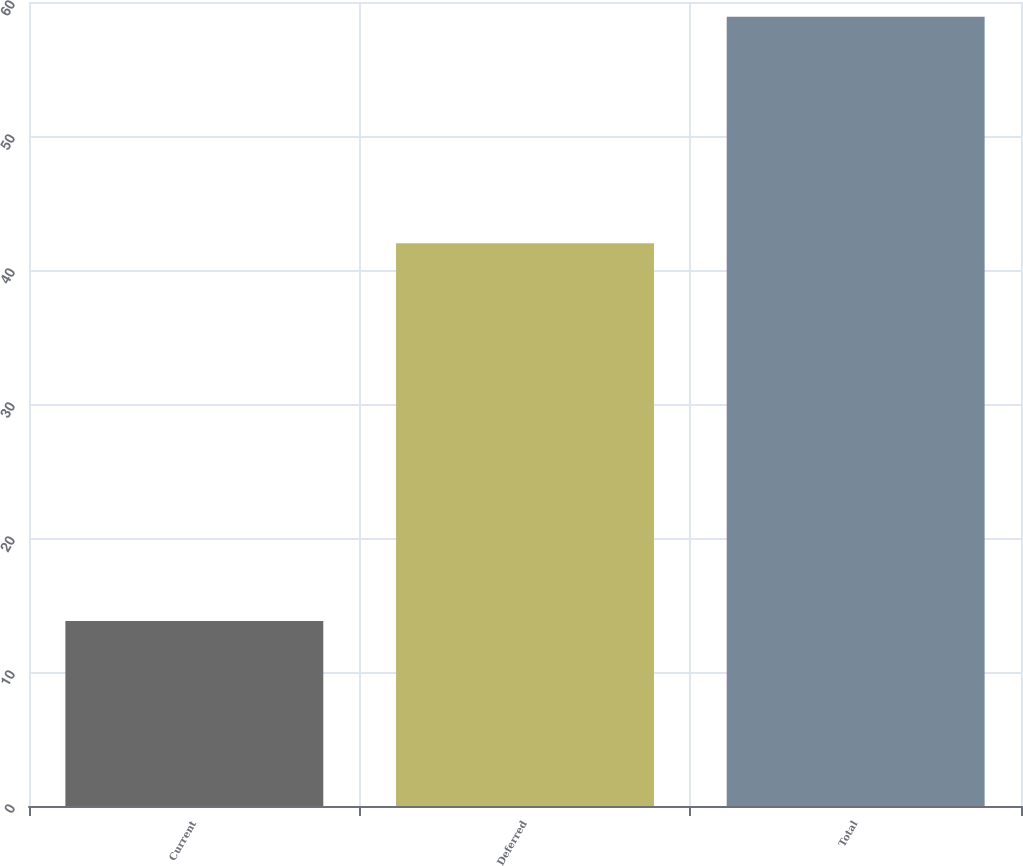<chart> <loc_0><loc_0><loc_500><loc_500><bar_chart><fcel>Current<fcel>Deferred<fcel>Total<nl><fcel>13.8<fcel>42<fcel>58.9<nl></chart> 